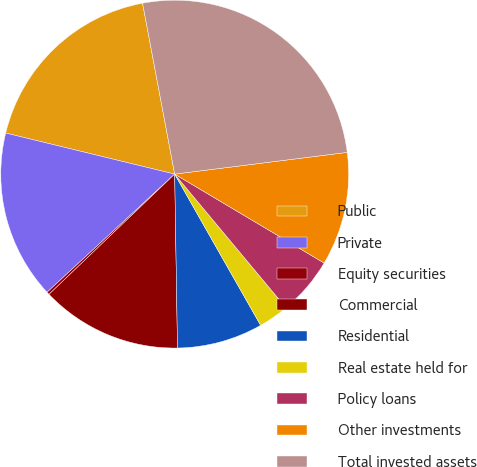<chart> <loc_0><loc_0><loc_500><loc_500><pie_chart><fcel>Public<fcel>Private<fcel>Equity securities<fcel>Commercial<fcel>Residential<fcel>Real estate held for<fcel>Policy loans<fcel>Other investments<fcel>Total invested assets<nl><fcel>18.25%<fcel>15.68%<fcel>0.26%<fcel>13.11%<fcel>7.97%<fcel>2.83%<fcel>5.4%<fcel>10.54%<fcel>25.96%<nl></chart> 